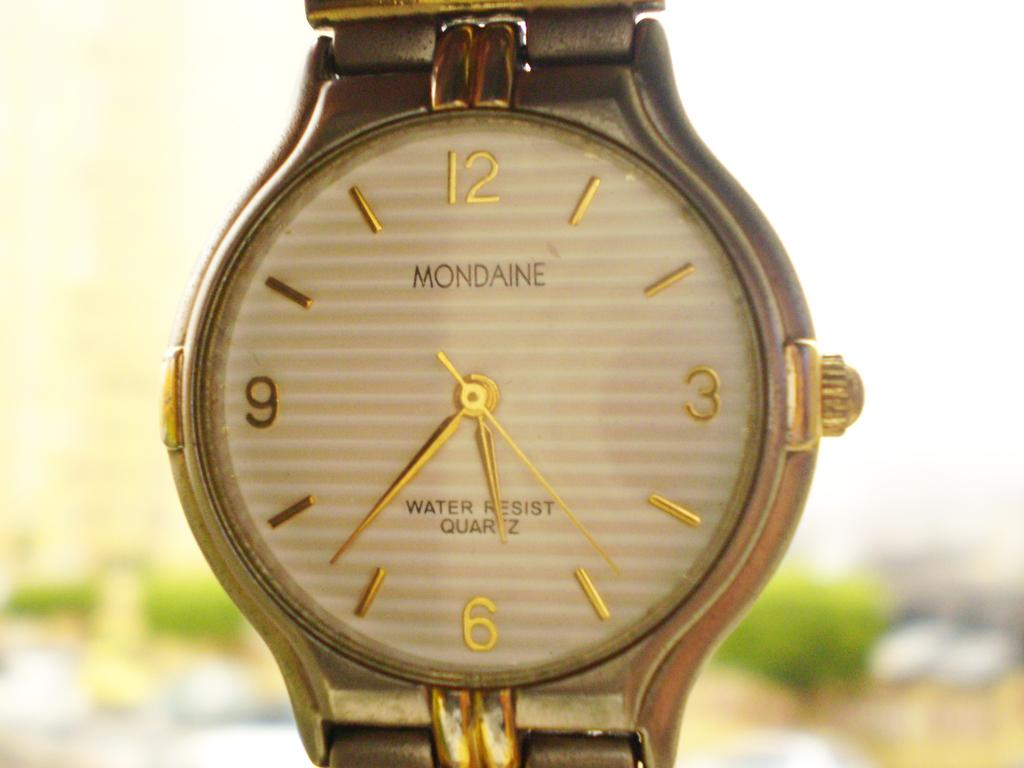<image>
Provide a brief description of the given image. A golden Mondaine watch with the time 6:35. 